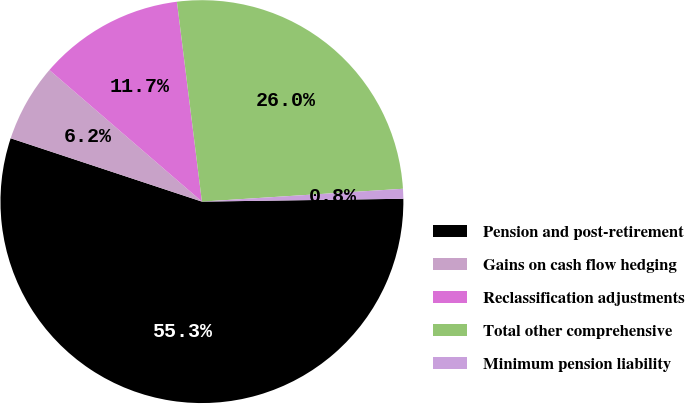Convert chart. <chart><loc_0><loc_0><loc_500><loc_500><pie_chart><fcel>Pension and post-retirement<fcel>Gains on cash flow hedging<fcel>Reclassification adjustments<fcel>Total other comprehensive<fcel>Minimum pension liability<nl><fcel>55.31%<fcel>6.24%<fcel>11.69%<fcel>25.96%<fcel>0.79%<nl></chart> 